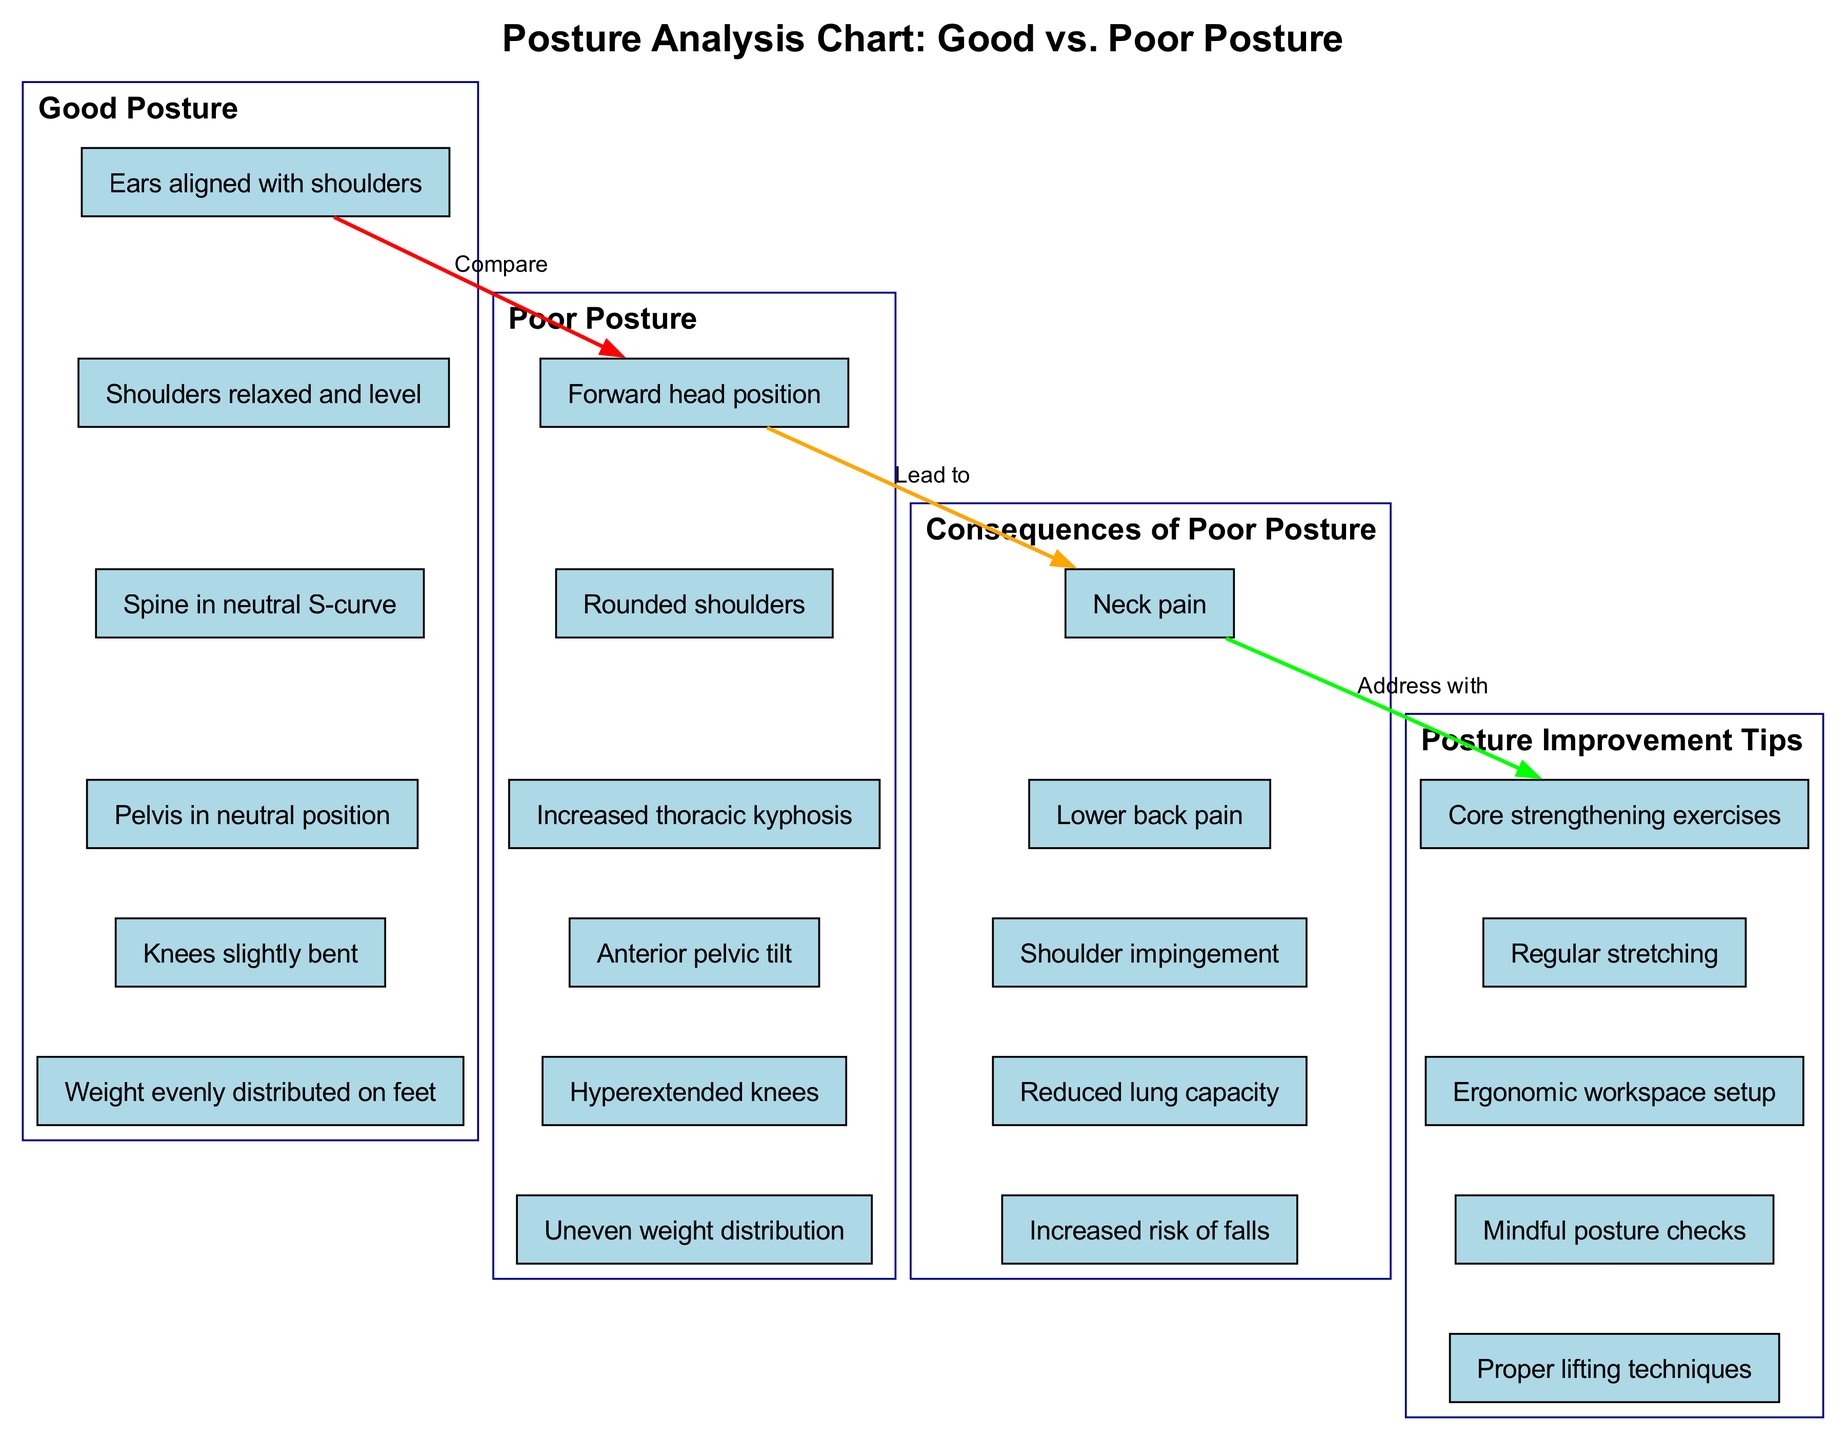What are the six elements listed under Good Posture? The diagram specifically lists six elements under the Good Posture section: "Ears aligned with shoulders," "Shoulders relaxed and level," "Spine in neutral S-curve," "Pelvis in neutral position," "Knees slightly bent," and "Weight evenly distributed on feet." I can identify all these elements as they are clearly enumerated in that section of the diagram.
Answer: Ears aligned with shoulders, Shoulders relaxed and level, Spine in neutral S-curve, Pelvis in neutral position, Knees slightly bent, Weight evenly distributed on feet What leads to consequences of Poor Posture? The diagram establishes a direct connection stating that Poor Posture leads to the consequences listed. The term "Lead to" is the label on the edge connecting the Poor Posture section to the Consequences of Poor Posture section, indicating that these consequences stem from poor posture habits.
Answer: Poor Posture How many total elements are listed under Consequences of Poor Posture? The Consequences of Poor Posture section contains five elements: "Neck pain," "Lower back pain," "Shoulder impingement," "Reduced lung capacity," and "Increased risk of falls." The count is derived by simply tallying the elements displayed in that section.
Answer: 5 What is the first tip listed for Posture Improvement? The Posture Improvement Tips section starts with "Core strengthening exercises." This is the first element listed under this section and can be identified directly as presented in the diagram.
Answer: Core strengthening exercises What color is used to represent the sections of the diagram? Each section is filled with light blue color as per the node attributes defined in the diagram creation. This uniform attribute applies to all nodes representing the various sections, ensuring visual consistency.
Answer: Light blue What is the relationship between Good Posture and Poor Posture in the diagram? The relationship is described as a comparative one, indicated by the edge labeled "Compare" connecting the Good Posture and Poor Posture sections. This highlights the intention of analyzing the differences between good and poor postural habits.
Answer: Compare 